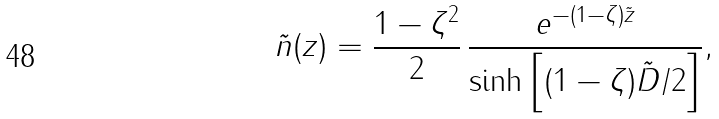Convert formula to latex. <formula><loc_0><loc_0><loc_500><loc_500>\tilde { n } ( z ) = \frac { 1 - \zeta ^ { 2 } } { 2 } \, \frac { e ^ { - ( 1 - \zeta ) \tilde { z } } } { \sinh \left [ ( 1 - \zeta ) \tilde { D } / 2 \right ] } ,</formula> 